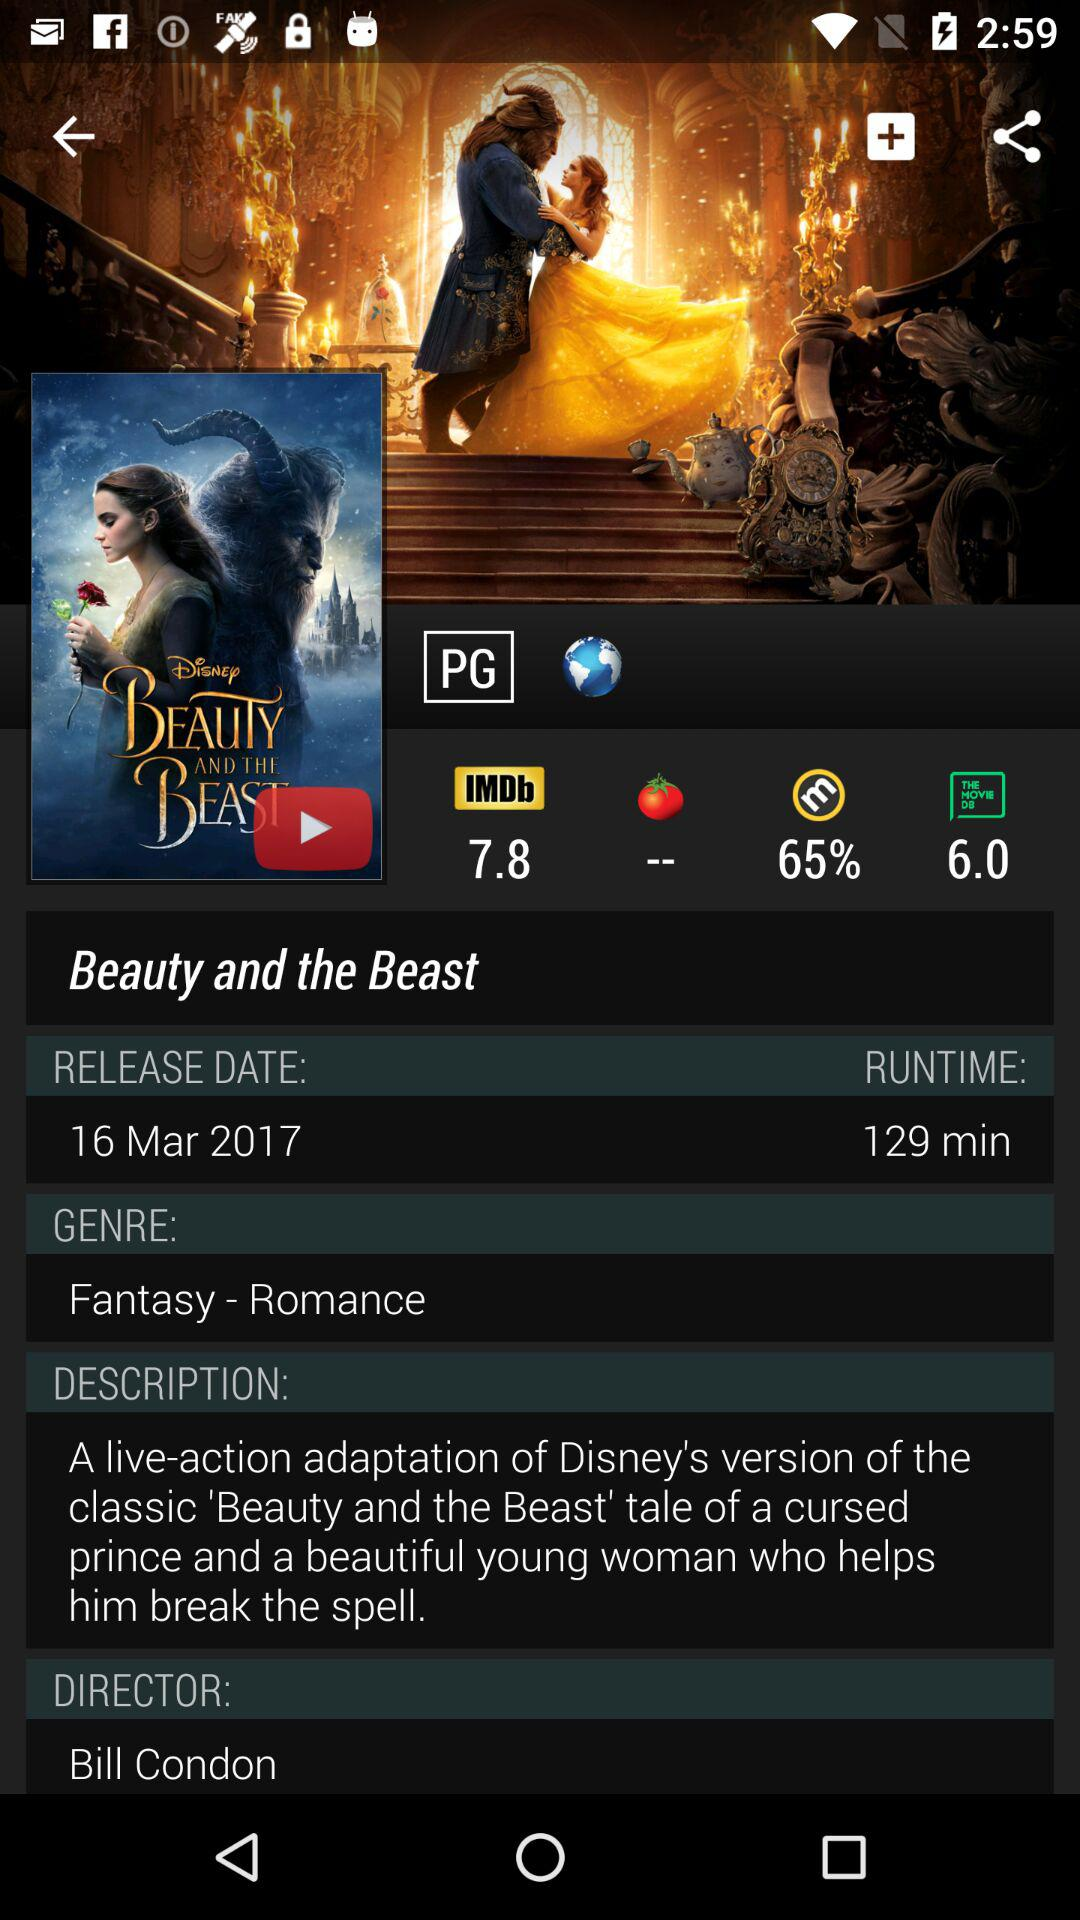What is the genre of Beauty and the Beast? The genre of Beauty and the Beast is "Fantasy - Romance". 